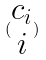<formula> <loc_0><loc_0><loc_500><loc_500>( \begin{matrix} c _ { i } \\ i \end{matrix} )</formula> 